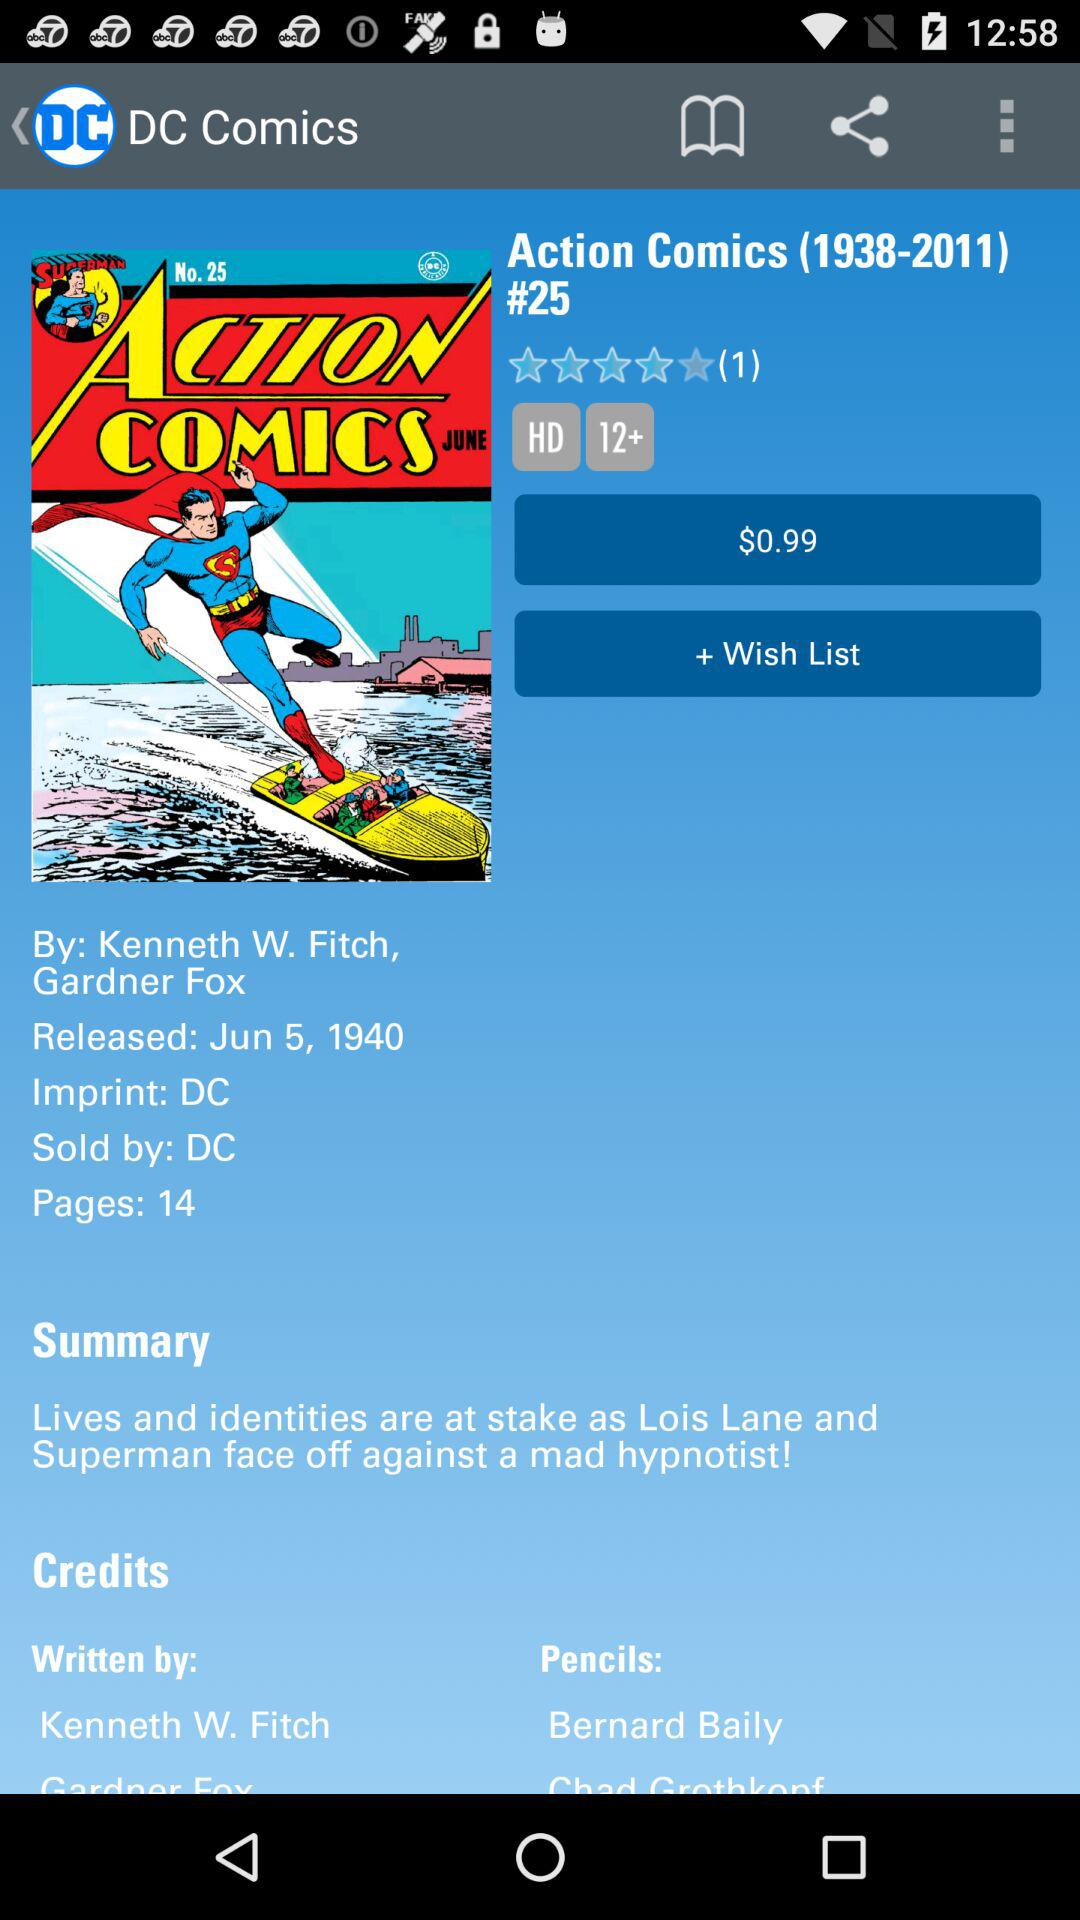What is the released date of the Action Comics? The released date is June 5, 1940. 